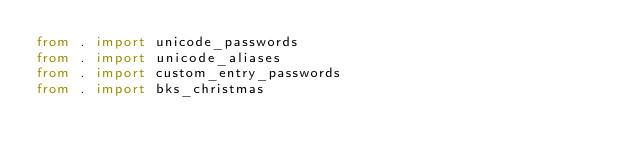Convert code to text. <code><loc_0><loc_0><loc_500><loc_500><_Python_>from . import unicode_passwords
from . import unicode_aliases
from . import custom_entry_passwords
from . import bks_christmas
</code> 